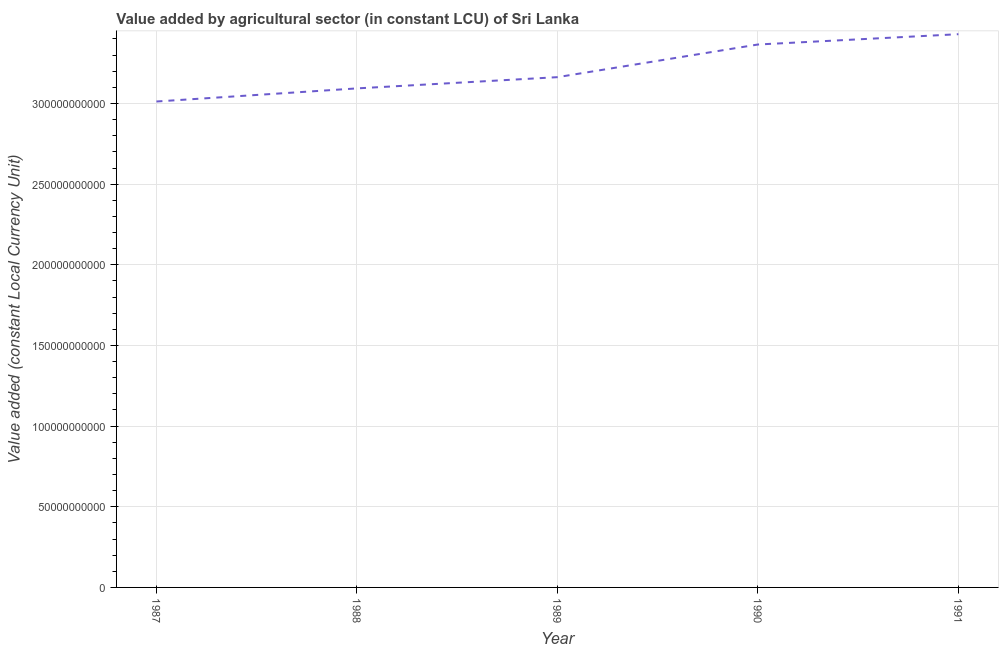What is the value added by agriculture sector in 1991?
Offer a very short reply. 3.43e+11. Across all years, what is the maximum value added by agriculture sector?
Offer a very short reply. 3.43e+11. Across all years, what is the minimum value added by agriculture sector?
Keep it short and to the point. 3.01e+11. In which year was the value added by agriculture sector maximum?
Make the answer very short. 1991. What is the sum of the value added by agriculture sector?
Keep it short and to the point. 1.61e+12. What is the difference between the value added by agriculture sector in 1989 and 1991?
Provide a short and direct response. -2.66e+1. What is the average value added by agriculture sector per year?
Your response must be concise. 3.21e+11. What is the median value added by agriculture sector?
Offer a terse response. 3.16e+11. What is the ratio of the value added by agriculture sector in 1987 to that in 1989?
Offer a very short reply. 0.95. Is the difference between the value added by agriculture sector in 1989 and 1991 greater than the difference between any two years?
Provide a succinct answer. No. What is the difference between the highest and the second highest value added by agriculture sector?
Keep it short and to the point. 6.39e+09. What is the difference between the highest and the lowest value added by agriculture sector?
Offer a very short reply. 4.17e+1. In how many years, is the value added by agriculture sector greater than the average value added by agriculture sector taken over all years?
Offer a very short reply. 2. How many years are there in the graph?
Give a very brief answer. 5. Does the graph contain any zero values?
Your response must be concise. No. Does the graph contain grids?
Your response must be concise. Yes. What is the title of the graph?
Provide a succinct answer. Value added by agricultural sector (in constant LCU) of Sri Lanka. What is the label or title of the Y-axis?
Keep it short and to the point. Value added (constant Local Currency Unit). What is the Value added (constant Local Currency Unit) in 1987?
Keep it short and to the point. 3.01e+11. What is the Value added (constant Local Currency Unit) in 1988?
Give a very brief answer. 3.09e+11. What is the Value added (constant Local Currency Unit) of 1989?
Ensure brevity in your answer.  3.16e+11. What is the Value added (constant Local Currency Unit) in 1990?
Give a very brief answer. 3.37e+11. What is the Value added (constant Local Currency Unit) in 1991?
Offer a terse response. 3.43e+11. What is the difference between the Value added (constant Local Currency Unit) in 1987 and 1988?
Provide a succinct answer. -8.13e+09. What is the difference between the Value added (constant Local Currency Unit) in 1987 and 1989?
Offer a terse response. -1.51e+1. What is the difference between the Value added (constant Local Currency Unit) in 1987 and 1990?
Keep it short and to the point. -3.53e+1. What is the difference between the Value added (constant Local Currency Unit) in 1987 and 1991?
Keep it short and to the point. -4.17e+1. What is the difference between the Value added (constant Local Currency Unit) in 1988 and 1989?
Your answer should be compact. -6.96e+09. What is the difference between the Value added (constant Local Currency Unit) in 1988 and 1990?
Offer a very short reply. -2.72e+1. What is the difference between the Value added (constant Local Currency Unit) in 1988 and 1991?
Offer a terse response. -3.36e+1. What is the difference between the Value added (constant Local Currency Unit) in 1989 and 1990?
Provide a short and direct response. -2.02e+1. What is the difference between the Value added (constant Local Currency Unit) in 1989 and 1991?
Offer a very short reply. -2.66e+1. What is the difference between the Value added (constant Local Currency Unit) in 1990 and 1991?
Your response must be concise. -6.39e+09. What is the ratio of the Value added (constant Local Currency Unit) in 1987 to that in 1988?
Your response must be concise. 0.97. What is the ratio of the Value added (constant Local Currency Unit) in 1987 to that in 1989?
Provide a short and direct response. 0.95. What is the ratio of the Value added (constant Local Currency Unit) in 1987 to that in 1990?
Provide a short and direct response. 0.9. What is the ratio of the Value added (constant Local Currency Unit) in 1987 to that in 1991?
Provide a short and direct response. 0.88. What is the ratio of the Value added (constant Local Currency Unit) in 1988 to that in 1990?
Your response must be concise. 0.92. What is the ratio of the Value added (constant Local Currency Unit) in 1988 to that in 1991?
Make the answer very short. 0.9. What is the ratio of the Value added (constant Local Currency Unit) in 1989 to that in 1990?
Your answer should be compact. 0.94. What is the ratio of the Value added (constant Local Currency Unit) in 1989 to that in 1991?
Give a very brief answer. 0.92. What is the ratio of the Value added (constant Local Currency Unit) in 1990 to that in 1991?
Give a very brief answer. 0.98. 